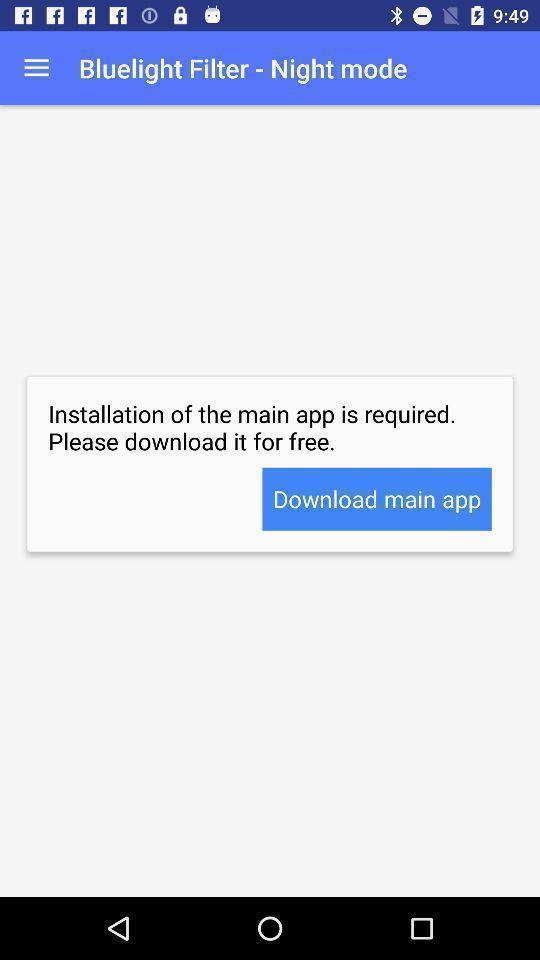Summarize the main components in this picture. Screen displaying the notification for installation. 